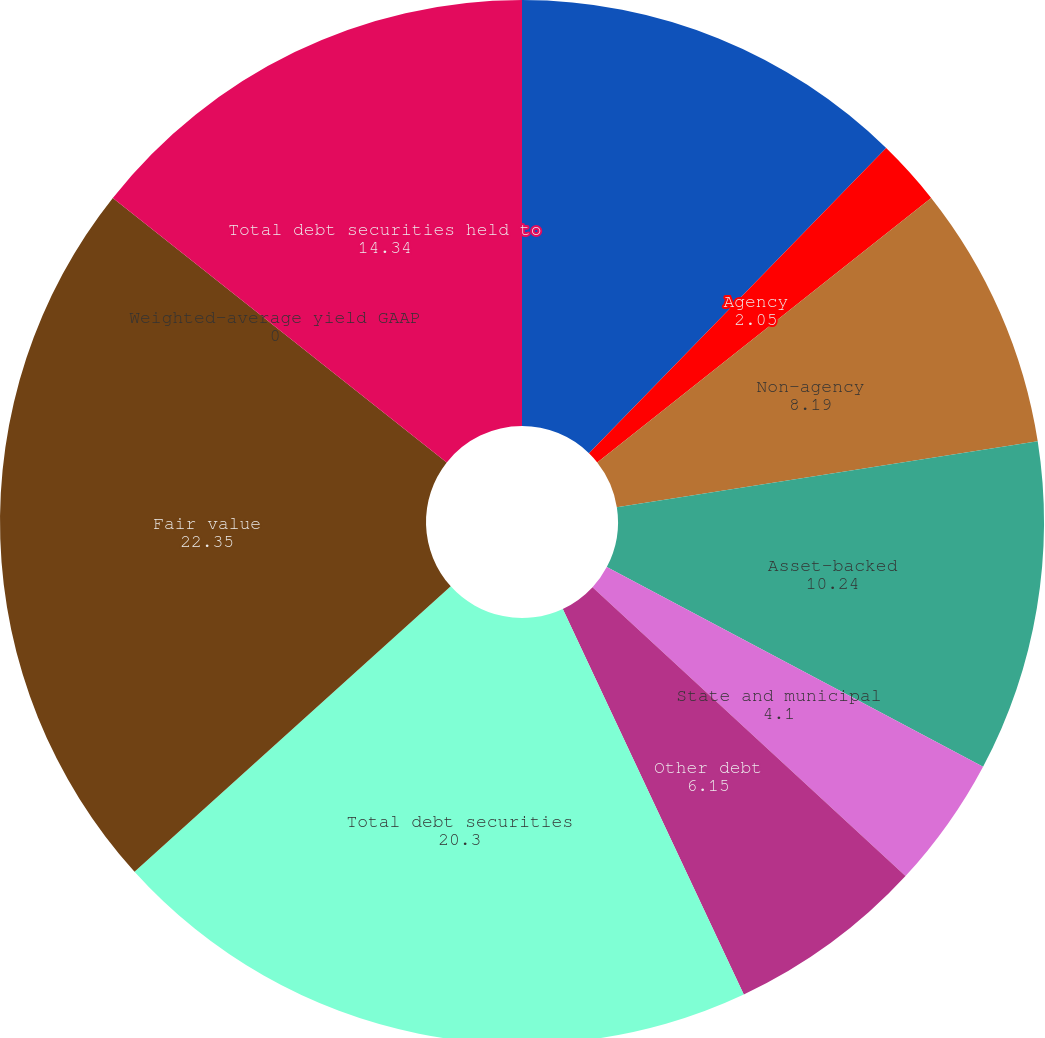<chart> <loc_0><loc_0><loc_500><loc_500><pie_chart><fcel>US Treasury and government<fcel>Agency<fcel>Non-agency<fcel>Asset-backed<fcel>State and municipal<fcel>Other debt<fcel>Total debt securities<fcel>Fair value<fcel>Weighted-average yield GAAP<fcel>Total debt securities held to<nl><fcel>12.29%<fcel>2.05%<fcel>8.19%<fcel>10.24%<fcel>4.1%<fcel>6.15%<fcel>20.3%<fcel>22.35%<fcel>0.0%<fcel>14.34%<nl></chart> 